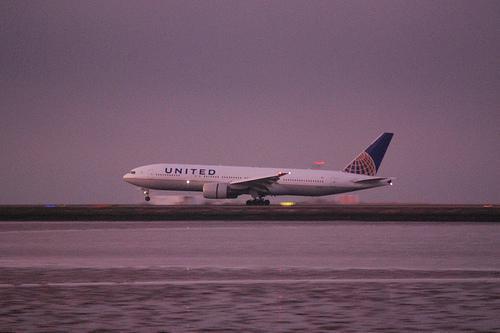How many airplanes are in the photo?
Give a very brief answer. 1. 